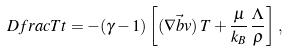<formula> <loc_0><loc_0><loc_500><loc_500>\ D f r a c { T } { t } = - ( \gamma - 1 ) \left [ ( \nabla \vec { b } { v } ) \, T + \frac { \mu } { k _ { B } } \, \frac { \Lambda } { \rho } \right ] \, ,</formula> 